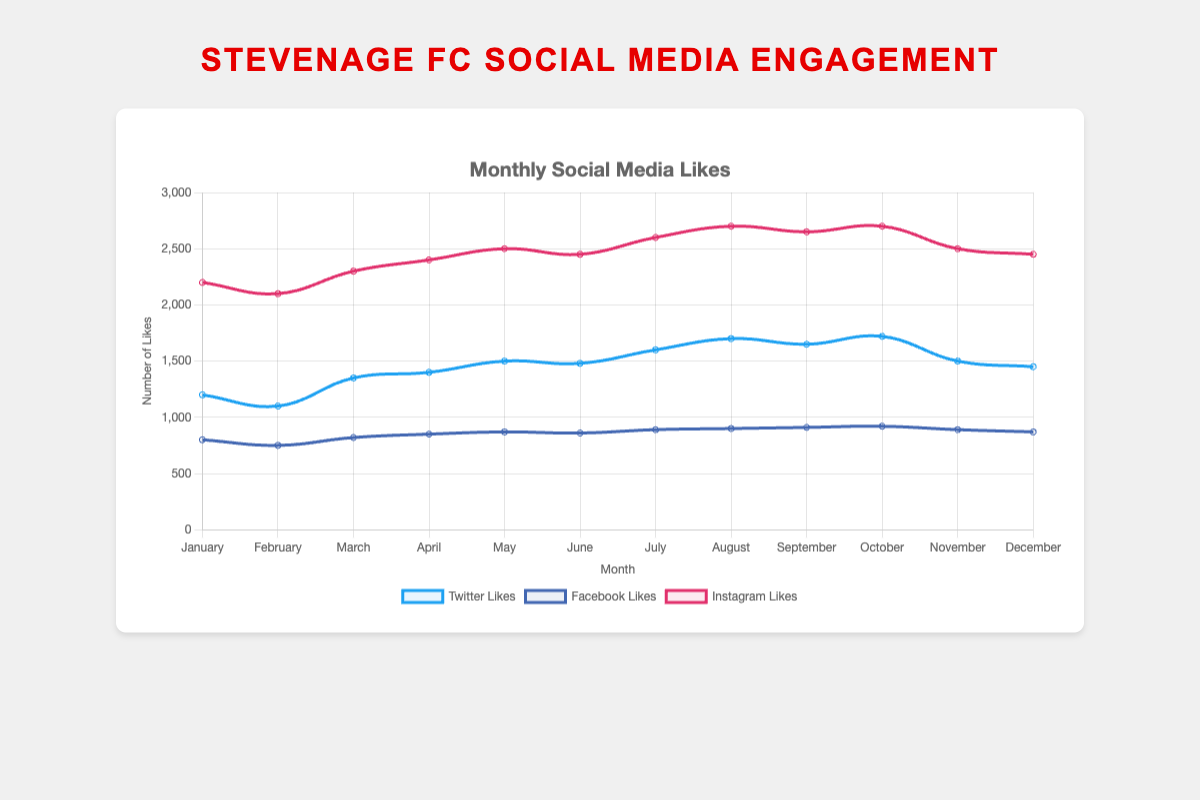Which social media platform had the highest number of likes in December? Looking at the plot, the Instagram line is the highest in December, indicating it has the most likes. Instagram had 2,450 likes.
Answer: Instagram How do the number of likes for Twitter compare to Facebook in June? The plot shows that Twitter has around 1,480 likes, while Facebook has around 860 likes in June. Twitter has more likes than Facebook in June.
Answer: Twitter has more What is the average number of likes on Instagram from July to September? The likes for Instagram from July to September are 2,600, 2,700, and 2,650. Summing these values gives 7,950, and dividing by 3 (months) gives an average of 2,650.
Answer: 2,650 In which month did Twitter have the lowest number of likes? The plot shows Twitter had the lowest likes in February at 1,100.
Answer: February Which platform saw the most significant increase in likes from January to February? Plotting the lines, Twitter increases from 1,200 to 1,100, Facebook from 800 to 750, and Instagram from 2,200 to 2,100. All platforms actually decreased in likes from January to February, so no platform had an increase.
Answer: None Compare the number of likes between Facebook and Instagram in October. Which had more? In October, Facebook had around 920 likes, while Instagram had around 2,700 likes. Instagram had more likes.
Answer: Instagram What is the general trend of likes on Facebook throughout the year? From January to December, Facebook likes generally trend upwards, starting at 800 and ending at 870 with minor fluctuations.
Answer: Upward trend Between which months did Instagram show its highest increase in likes? From the plot, Instagram's likes increased most significantly from June (2,450) to July (2,600), a difference of 150 likes.
Answer: June to July What is the combined average number of likes for all platforms in March? The number of likes in March are Twitter (1,350), Facebook (820), and Instagram (2,300). Sum these values (1,350 + 820 + 2,300 = 4,470) and divide by 3 (platforms), the average is 1,490.
Answer: 1,490 Which month shows the highest engagement in likes for any platform, and which platform is it? Looking at the highest peaks in the plot, Instagram in October shows the highest likes at 2,700.
Answer: October, Instagram 